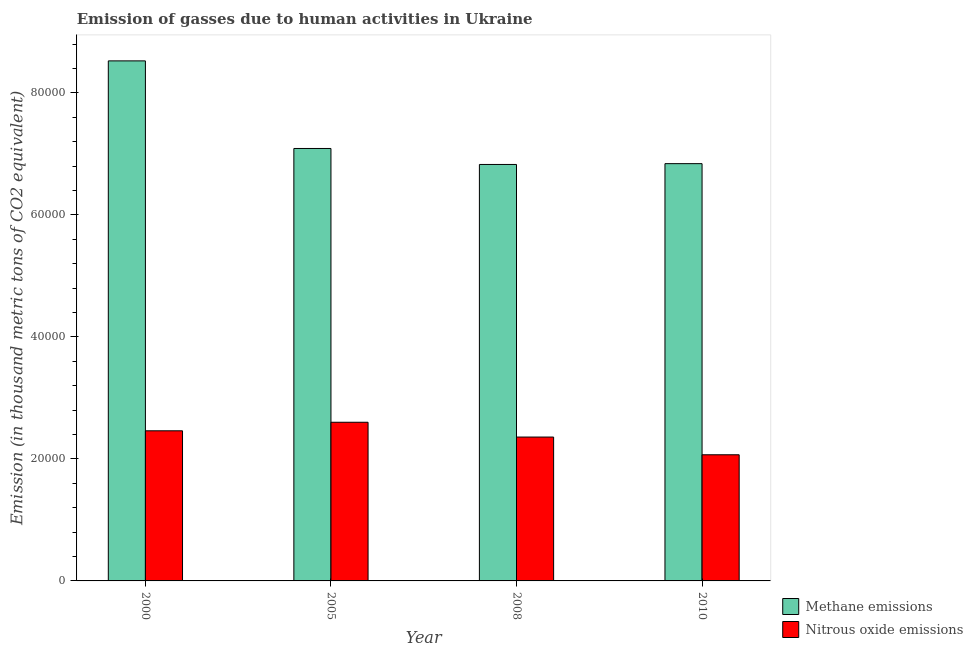How many groups of bars are there?
Your answer should be very brief. 4. Are the number of bars per tick equal to the number of legend labels?
Your response must be concise. Yes. Are the number of bars on each tick of the X-axis equal?
Offer a terse response. Yes. How many bars are there on the 3rd tick from the left?
Ensure brevity in your answer.  2. How many bars are there on the 2nd tick from the right?
Provide a short and direct response. 2. What is the label of the 1st group of bars from the left?
Your response must be concise. 2000. In how many cases, is the number of bars for a given year not equal to the number of legend labels?
Give a very brief answer. 0. What is the amount of nitrous oxide emissions in 2005?
Your response must be concise. 2.60e+04. Across all years, what is the maximum amount of methane emissions?
Provide a succinct answer. 8.52e+04. Across all years, what is the minimum amount of nitrous oxide emissions?
Provide a succinct answer. 2.07e+04. In which year was the amount of methane emissions minimum?
Provide a short and direct response. 2008. What is the total amount of methane emissions in the graph?
Offer a terse response. 2.93e+05. What is the difference between the amount of methane emissions in 2008 and that in 2010?
Your response must be concise. -132.4. What is the difference between the amount of nitrous oxide emissions in 2000 and the amount of methane emissions in 2005?
Your answer should be compact. -1402.1. What is the average amount of nitrous oxide emissions per year?
Provide a short and direct response. 2.37e+04. What is the ratio of the amount of methane emissions in 2005 to that in 2010?
Keep it short and to the point. 1.04. Is the amount of methane emissions in 2000 less than that in 2010?
Your answer should be compact. No. What is the difference between the highest and the second highest amount of nitrous oxide emissions?
Your response must be concise. 1402.1. What is the difference between the highest and the lowest amount of methane emissions?
Ensure brevity in your answer.  1.70e+04. In how many years, is the amount of nitrous oxide emissions greater than the average amount of nitrous oxide emissions taken over all years?
Keep it short and to the point. 2. What does the 2nd bar from the left in 2010 represents?
Provide a succinct answer. Nitrous oxide emissions. What does the 2nd bar from the right in 2005 represents?
Provide a succinct answer. Methane emissions. Are all the bars in the graph horizontal?
Offer a very short reply. No. How many years are there in the graph?
Provide a succinct answer. 4. What is the difference between two consecutive major ticks on the Y-axis?
Ensure brevity in your answer.  2.00e+04. Are the values on the major ticks of Y-axis written in scientific E-notation?
Provide a short and direct response. No. How many legend labels are there?
Ensure brevity in your answer.  2. What is the title of the graph?
Give a very brief answer. Emission of gasses due to human activities in Ukraine. What is the label or title of the Y-axis?
Provide a short and direct response. Emission (in thousand metric tons of CO2 equivalent). What is the Emission (in thousand metric tons of CO2 equivalent) in Methane emissions in 2000?
Offer a terse response. 8.52e+04. What is the Emission (in thousand metric tons of CO2 equivalent) of Nitrous oxide emissions in 2000?
Your answer should be compact. 2.46e+04. What is the Emission (in thousand metric tons of CO2 equivalent) in Methane emissions in 2005?
Offer a terse response. 7.09e+04. What is the Emission (in thousand metric tons of CO2 equivalent) in Nitrous oxide emissions in 2005?
Offer a very short reply. 2.60e+04. What is the Emission (in thousand metric tons of CO2 equivalent) in Methane emissions in 2008?
Your response must be concise. 6.83e+04. What is the Emission (in thousand metric tons of CO2 equivalent) in Nitrous oxide emissions in 2008?
Make the answer very short. 2.36e+04. What is the Emission (in thousand metric tons of CO2 equivalent) in Methane emissions in 2010?
Offer a very short reply. 6.84e+04. What is the Emission (in thousand metric tons of CO2 equivalent) in Nitrous oxide emissions in 2010?
Provide a short and direct response. 2.07e+04. Across all years, what is the maximum Emission (in thousand metric tons of CO2 equivalent) of Methane emissions?
Ensure brevity in your answer.  8.52e+04. Across all years, what is the maximum Emission (in thousand metric tons of CO2 equivalent) in Nitrous oxide emissions?
Give a very brief answer. 2.60e+04. Across all years, what is the minimum Emission (in thousand metric tons of CO2 equivalent) of Methane emissions?
Provide a short and direct response. 6.83e+04. Across all years, what is the minimum Emission (in thousand metric tons of CO2 equivalent) in Nitrous oxide emissions?
Make the answer very short. 2.07e+04. What is the total Emission (in thousand metric tons of CO2 equivalent) in Methane emissions in the graph?
Ensure brevity in your answer.  2.93e+05. What is the total Emission (in thousand metric tons of CO2 equivalent) of Nitrous oxide emissions in the graph?
Keep it short and to the point. 9.49e+04. What is the difference between the Emission (in thousand metric tons of CO2 equivalent) in Methane emissions in 2000 and that in 2005?
Offer a very short reply. 1.44e+04. What is the difference between the Emission (in thousand metric tons of CO2 equivalent) of Nitrous oxide emissions in 2000 and that in 2005?
Offer a terse response. -1402.1. What is the difference between the Emission (in thousand metric tons of CO2 equivalent) of Methane emissions in 2000 and that in 2008?
Ensure brevity in your answer.  1.70e+04. What is the difference between the Emission (in thousand metric tons of CO2 equivalent) in Nitrous oxide emissions in 2000 and that in 2008?
Offer a terse response. 1024.6. What is the difference between the Emission (in thousand metric tons of CO2 equivalent) of Methane emissions in 2000 and that in 2010?
Make the answer very short. 1.68e+04. What is the difference between the Emission (in thousand metric tons of CO2 equivalent) of Nitrous oxide emissions in 2000 and that in 2010?
Your answer should be compact. 3929.5. What is the difference between the Emission (in thousand metric tons of CO2 equivalent) in Methane emissions in 2005 and that in 2008?
Offer a very short reply. 2618.6. What is the difference between the Emission (in thousand metric tons of CO2 equivalent) in Nitrous oxide emissions in 2005 and that in 2008?
Offer a terse response. 2426.7. What is the difference between the Emission (in thousand metric tons of CO2 equivalent) in Methane emissions in 2005 and that in 2010?
Give a very brief answer. 2486.2. What is the difference between the Emission (in thousand metric tons of CO2 equivalent) of Nitrous oxide emissions in 2005 and that in 2010?
Your answer should be very brief. 5331.6. What is the difference between the Emission (in thousand metric tons of CO2 equivalent) in Methane emissions in 2008 and that in 2010?
Offer a terse response. -132.4. What is the difference between the Emission (in thousand metric tons of CO2 equivalent) in Nitrous oxide emissions in 2008 and that in 2010?
Offer a terse response. 2904.9. What is the difference between the Emission (in thousand metric tons of CO2 equivalent) in Methane emissions in 2000 and the Emission (in thousand metric tons of CO2 equivalent) in Nitrous oxide emissions in 2005?
Offer a terse response. 5.92e+04. What is the difference between the Emission (in thousand metric tons of CO2 equivalent) in Methane emissions in 2000 and the Emission (in thousand metric tons of CO2 equivalent) in Nitrous oxide emissions in 2008?
Your answer should be very brief. 6.17e+04. What is the difference between the Emission (in thousand metric tons of CO2 equivalent) in Methane emissions in 2000 and the Emission (in thousand metric tons of CO2 equivalent) in Nitrous oxide emissions in 2010?
Offer a very short reply. 6.46e+04. What is the difference between the Emission (in thousand metric tons of CO2 equivalent) of Methane emissions in 2005 and the Emission (in thousand metric tons of CO2 equivalent) of Nitrous oxide emissions in 2008?
Offer a terse response. 4.73e+04. What is the difference between the Emission (in thousand metric tons of CO2 equivalent) in Methane emissions in 2005 and the Emission (in thousand metric tons of CO2 equivalent) in Nitrous oxide emissions in 2010?
Provide a short and direct response. 5.02e+04. What is the difference between the Emission (in thousand metric tons of CO2 equivalent) in Methane emissions in 2008 and the Emission (in thousand metric tons of CO2 equivalent) in Nitrous oxide emissions in 2010?
Your answer should be compact. 4.76e+04. What is the average Emission (in thousand metric tons of CO2 equivalent) in Methane emissions per year?
Keep it short and to the point. 7.32e+04. What is the average Emission (in thousand metric tons of CO2 equivalent) of Nitrous oxide emissions per year?
Keep it short and to the point. 2.37e+04. In the year 2000, what is the difference between the Emission (in thousand metric tons of CO2 equivalent) in Methane emissions and Emission (in thousand metric tons of CO2 equivalent) in Nitrous oxide emissions?
Your response must be concise. 6.06e+04. In the year 2005, what is the difference between the Emission (in thousand metric tons of CO2 equivalent) in Methane emissions and Emission (in thousand metric tons of CO2 equivalent) in Nitrous oxide emissions?
Make the answer very short. 4.49e+04. In the year 2008, what is the difference between the Emission (in thousand metric tons of CO2 equivalent) in Methane emissions and Emission (in thousand metric tons of CO2 equivalent) in Nitrous oxide emissions?
Provide a succinct answer. 4.47e+04. In the year 2010, what is the difference between the Emission (in thousand metric tons of CO2 equivalent) of Methane emissions and Emission (in thousand metric tons of CO2 equivalent) of Nitrous oxide emissions?
Ensure brevity in your answer.  4.77e+04. What is the ratio of the Emission (in thousand metric tons of CO2 equivalent) in Methane emissions in 2000 to that in 2005?
Give a very brief answer. 1.2. What is the ratio of the Emission (in thousand metric tons of CO2 equivalent) of Nitrous oxide emissions in 2000 to that in 2005?
Keep it short and to the point. 0.95. What is the ratio of the Emission (in thousand metric tons of CO2 equivalent) of Methane emissions in 2000 to that in 2008?
Keep it short and to the point. 1.25. What is the ratio of the Emission (in thousand metric tons of CO2 equivalent) in Nitrous oxide emissions in 2000 to that in 2008?
Give a very brief answer. 1.04. What is the ratio of the Emission (in thousand metric tons of CO2 equivalent) of Methane emissions in 2000 to that in 2010?
Your response must be concise. 1.25. What is the ratio of the Emission (in thousand metric tons of CO2 equivalent) of Nitrous oxide emissions in 2000 to that in 2010?
Your response must be concise. 1.19. What is the ratio of the Emission (in thousand metric tons of CO2 equivalent) in Methane emissions in 2005 to that in 2008?
Provide a short and direct response. 1.04. What is the ratio of the Emission (in thousand metric tons of CO2 equivalent) of Nitrous oxide emissions in 2005 to that in 2008?
Offer a very short reply. 1.1. What is the ratio of the Emission (in thousand metric tons of CO2 equivalent) of Methane emissions in 2005 to that in 2010?
Make the answer very short. 1.04. What is the ratio of the Emission (in thousand metric tons of CO2 equivalent) of Nitrous oxide emissions in 2005 to that in 2010?
Make the answer very short. 1.26. What is the ratio of the Emission (in thousand metric tons of CO2 equivalent) in Nitrous oxide emissions in 2008 to that in 2010?
Offer a terse response. 1.14. What is the difference between the highest and the second highest Emission (in thousand metric tons of CO2 equivalent) in Methane emissions?
Keep it short and to the point. 1.44e+04. What is the difference between the highest and the second highest Emission (in thousand metric tons of CO2 equivalent) in Nitrous oxide emissions?
Give a very brief answer. 1402.1. What is the difference between the highest and the lowest Emission (in thousand metric tons of CO2 equivalent) of Methane emissions?
Offer a terse response. 1.70e+04. What is the difference between the highest and the lowest Emission (in thousand metric tons of CO2 equivalent) of Nitrous oxide emissions?
Provide a short and direct response. 5331.6. 